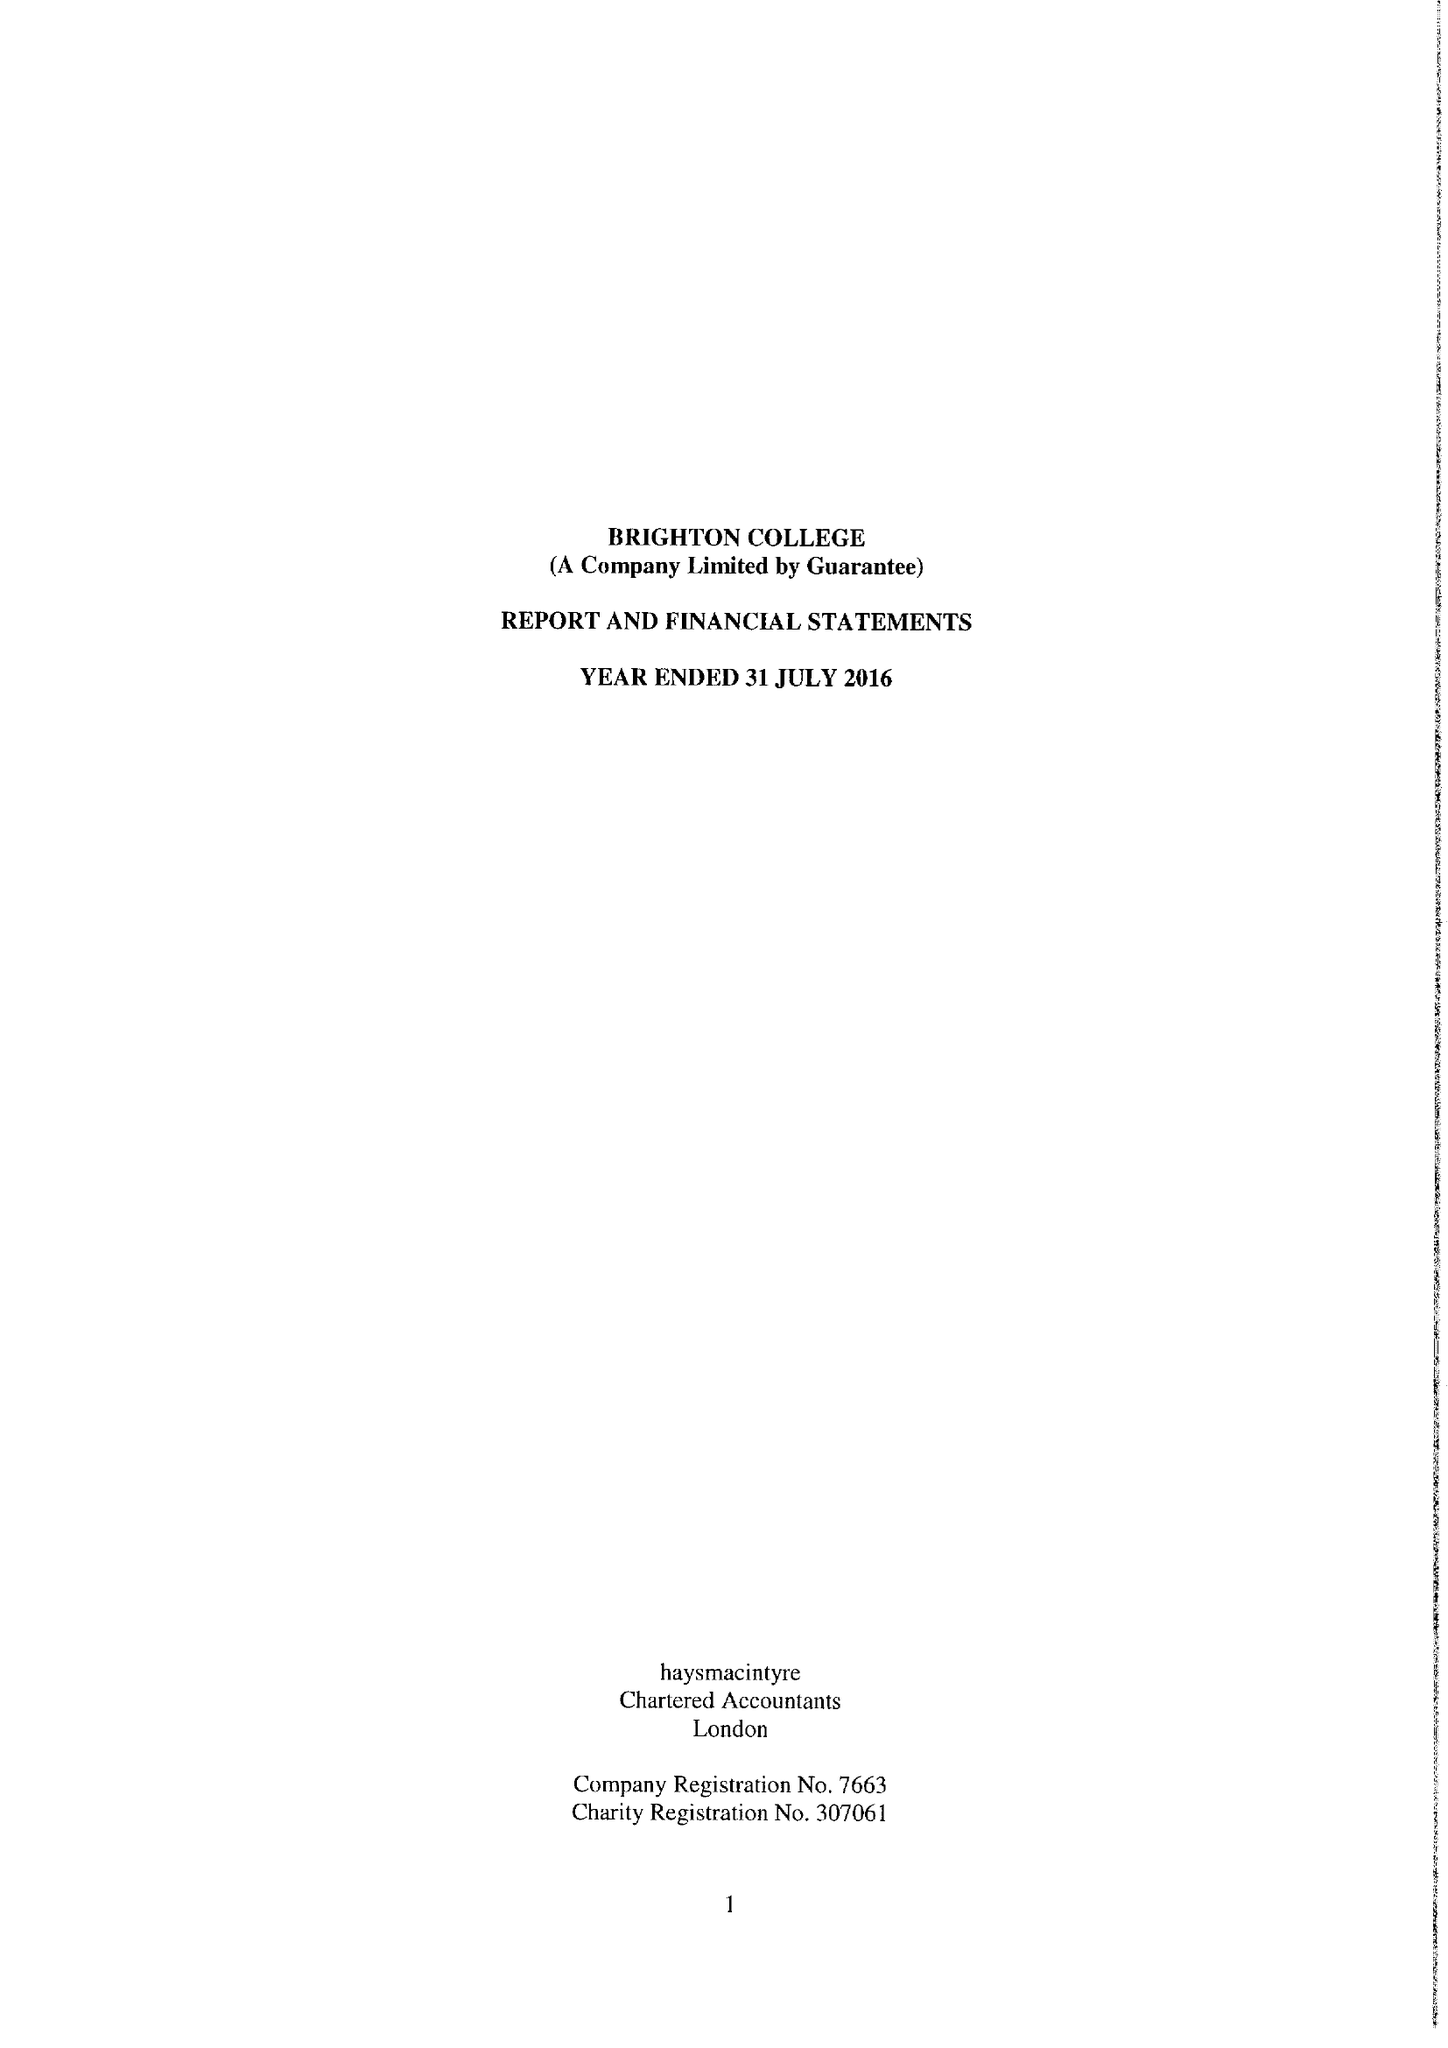What is the value for the income_annually_in_british_pounds?
Answer the question using a single word or phrase. 49091964.00 